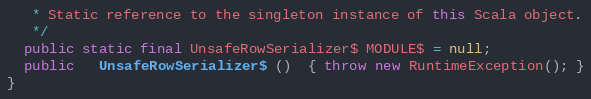Convert code to text. <code><loc_0><loc_0><loc_500><loc_500><_Java_>   * Static reference to the singleton instance of this Scala object.
   */
  public static final UnsafeRowSerializer$ MODULE$ = null;
  public   UnsafeRowSerializer$ ()  { throw new RuntimeException(); }
}
</code> 